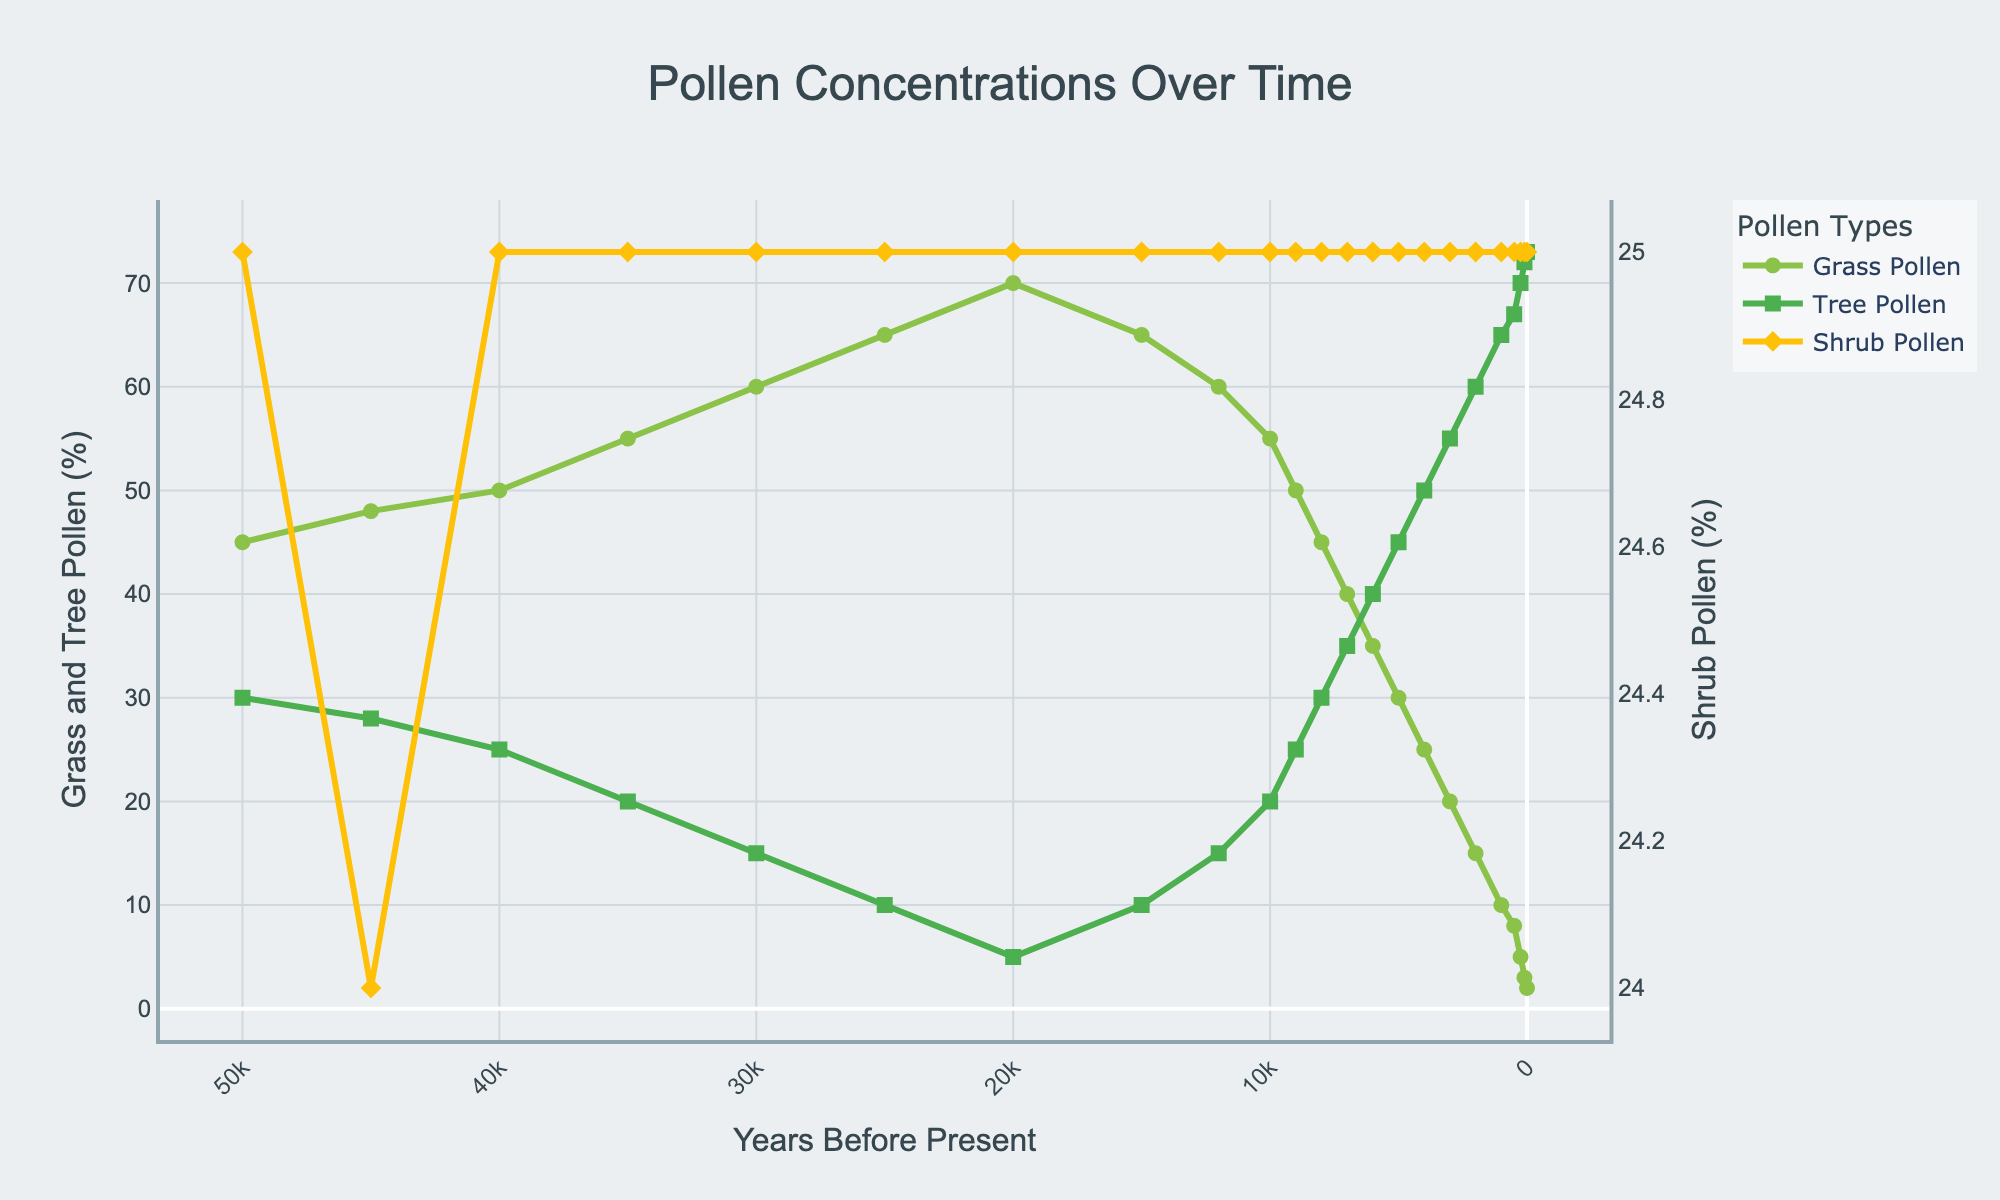What is the concentration of grass pollen 50,000 years before present? First, locate the point on the graph where the x-axis (Years BP) is 50,000. Then, read the corresponding value on the y-axis for Grass Pollen (%), which is marked in green. The value is 45%.
Answer: 45% What trend can you observe in the grass pollen concentrations over the 50,000-year period? Observing the plot for Grass Pollen (%), we see that it starts high at 45% and generally increases until around 20,000 BP, when it peaks at 70%. After that, it begins to decrease, ultimately reaching 2% in the present.
Answer: Grass pollen concentrations initially increased and then decreased over time Between what range of years does tree pollen show a continuous increasing trend? Look at the plot for Tree Pollen (%). The continuous increasing trend starts at 12,000 years BP where it is 15% and continues to increase until the present, where it reaches 73%.
Answer: 12,000 BP to present At which year before present do grass and tree pollen concentrations intersect? Locate the points where Grass Pollen (%) and Tree Pollen (%) intersect on the graph. This intersection occurs around 8,000 years BP, with both being approximately 45%.
Answer: 8000 BP How does shrub pollen concentration change over the 50,000 years? Look at the plot for Shrub Pollen (%), which is consistently 25% throughout the entire 50,000-year period with no variation.
Answer: It remains constant What is the combined percentage of tree and shrub pollen 40,000 years before present? Find the values for Tree Pollen (%) and Shrub Pollen (%) at 40,000 BP, which are 25% and 25%, respectively. Their sum is 25% + 25% = 50%.
Answer: 50% Compare the rate of change in tree pollen versus grass pollen concentrations between 10,000 and 0 years before present. Which had a more significant change? Calculate the difference for each: Tree Pollen (%) increases from 20% to 73%, a change of 53%. Grass Pollen (%) decreases from 55% to 2%, a change of 53%. Both have an equal magnitude of change, 53%.
Answer: Both had equal significant changes When did tree pollen percentages exceed 50% for the first time? Identify the year before present where the Tree Pollen (%) first reaches above 50%. This happens between 4,000 BP when it is 50% and 3,000 BP when it is 55%. Hence, it first exceeds 50% at 3,000 BP.
Answer: 3000 BP On which side of the vertical axis does the higher percentage of tree pollen appear? Tree Pollen (%) is plotted with green squares and it always appears on the left y-axis since it ranges up to 73%, which is higher than the right y-axis range for Shrub Pollen (%), which is 25%.
Answer: Left Estimate the period when grass pollen concentration is declining, and tree pollen concentration is rising simultaneously without intersecting. Look for periods where Grass Pollen (%) is decreasing and Tree Pollen (%) is increasing but not intersecting. This occurs from roughly 20,000 BP to around 8,000 BP.
Answer: 20,000 BP to 8,000 BP 